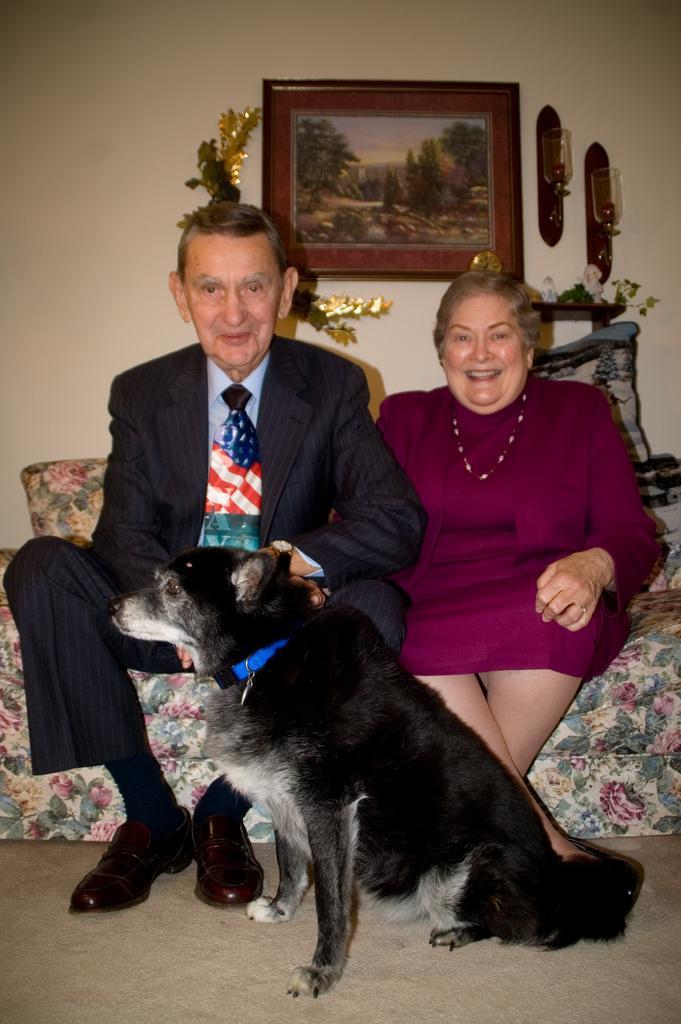Can you describe this image briefly? a black colored dog is sitting on the floor. behind him there are 2 people sitting on a floral sofa. behind them there is a wall on which a photo frame is hanged. 